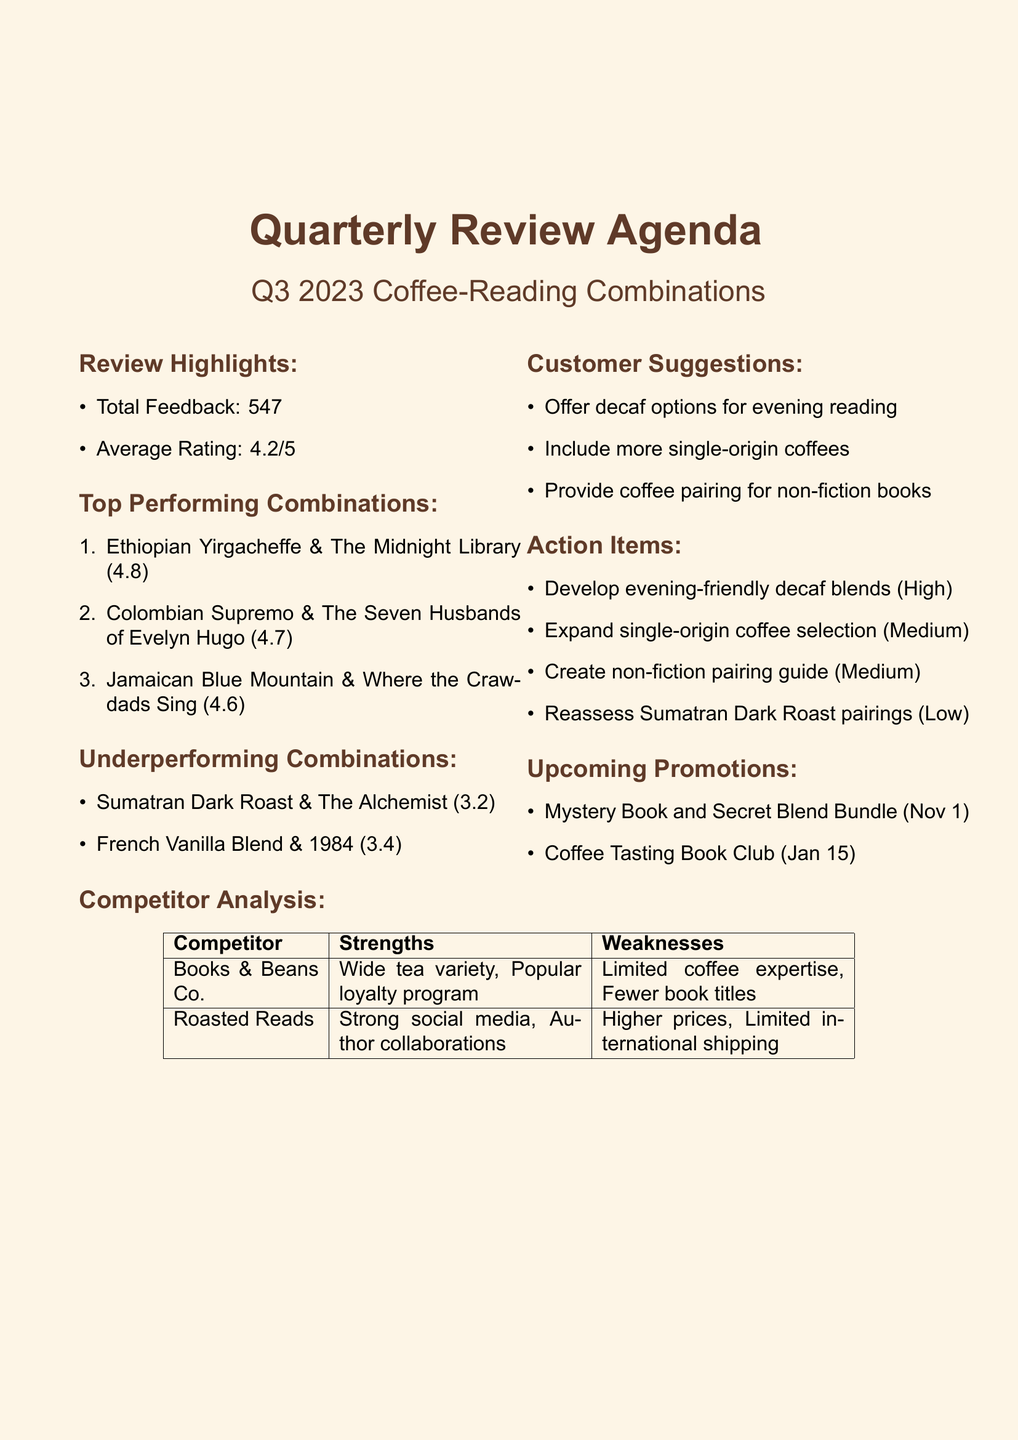What was the total feedback received? The total feedback represents the number of customer responses collected during the review period, which is stated as 547.
Answer: 547 What is the average rating of the coffee-reading combinations? The average rating is provided in the document, reflecting customer satisfaction, which is 4.2.
Answer: 4.2 Which coffee and book combination had the highest rating? The highest-rated combination is found in the top-performing list, which is "Ethiopian Yirgacheffe & The Midnight Library."
Answer: Ethiopian Yirgacheffe & The Midnight Library What was the rating of the Sumatran Dark Roast and The Alchemist pairing? The rating for this particular underperforming combination is noted in the document, which is 3.2.
Answer: 3.2 How many customer suggestions were received for offering decaf options? The frequency of this specific suggestion is highlighted in the customer suggestions section, amounting to 37.
Answer: 37 What is one of the action items assigned to the Product Development Team? The action item concerning decaf blends, which is highly prioritized, is assigned to the Product Development Team.
Answer: Develop evening-friendly decaf blends What are the launch dates of the upcoming promotions? The document lists the launch dates, which are November 1, 2023, and January 15, 2024.
Answer: November 1, 2023 and January 15, 2024 What unique feature does "Roasted Reads" have according to the competitor analysis? The strengths section of the competitor analysis states that "Roasted Reads" has a strong social media presence.
Answer: Strong social media presence What is the priority level for expanding the single-origin coffee selection? The document categorizes this action item as having a medium priority level.
Answer: Medium 